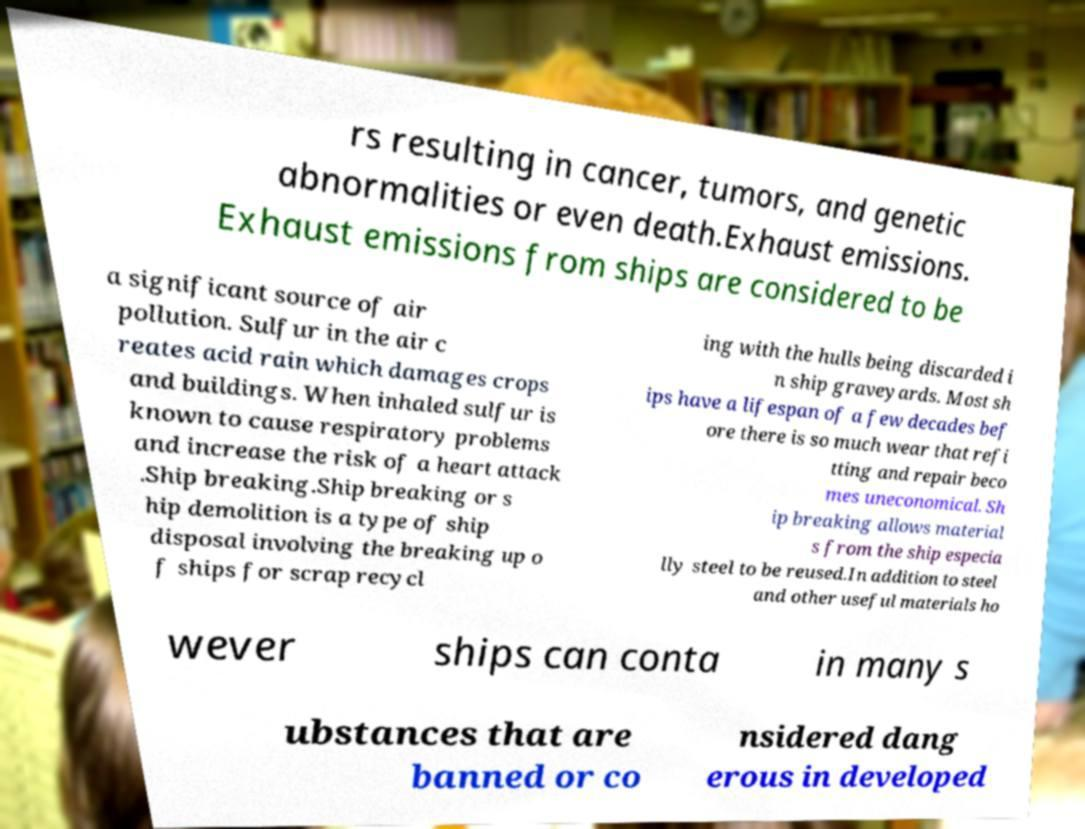There's text embedded in this image that I need extracted. Can you transcribe it verbatim? rs resulting in cancer, tumors, and genetic abnormalities or even death.Exhaust emissions. Exhaust emissions from ships are considered to be a significant source of air pollution. Sulfur in the air c reates acid rain which damages crops and buildings. When inhaled sulfur is known to cause respiratory problems and increase the risk of a heart attack .Ship breaking.Ship breaking or s hip demolition is a type of ship disposal involving the breaking up o f ships for scrap recycl ing with the hulls being discarded i n ship graveyards. Most sh ips have a lifespan of a few decades bef ore there is so much wear that refi tting and repair beco mes uneconomical. Sh ip breaking allows material s from the ship especia lly steel to be reused.In addition to steel and other useful materials ho wever ships can conta in many s ubstances that are banned or co nsidered dang erous in developed 